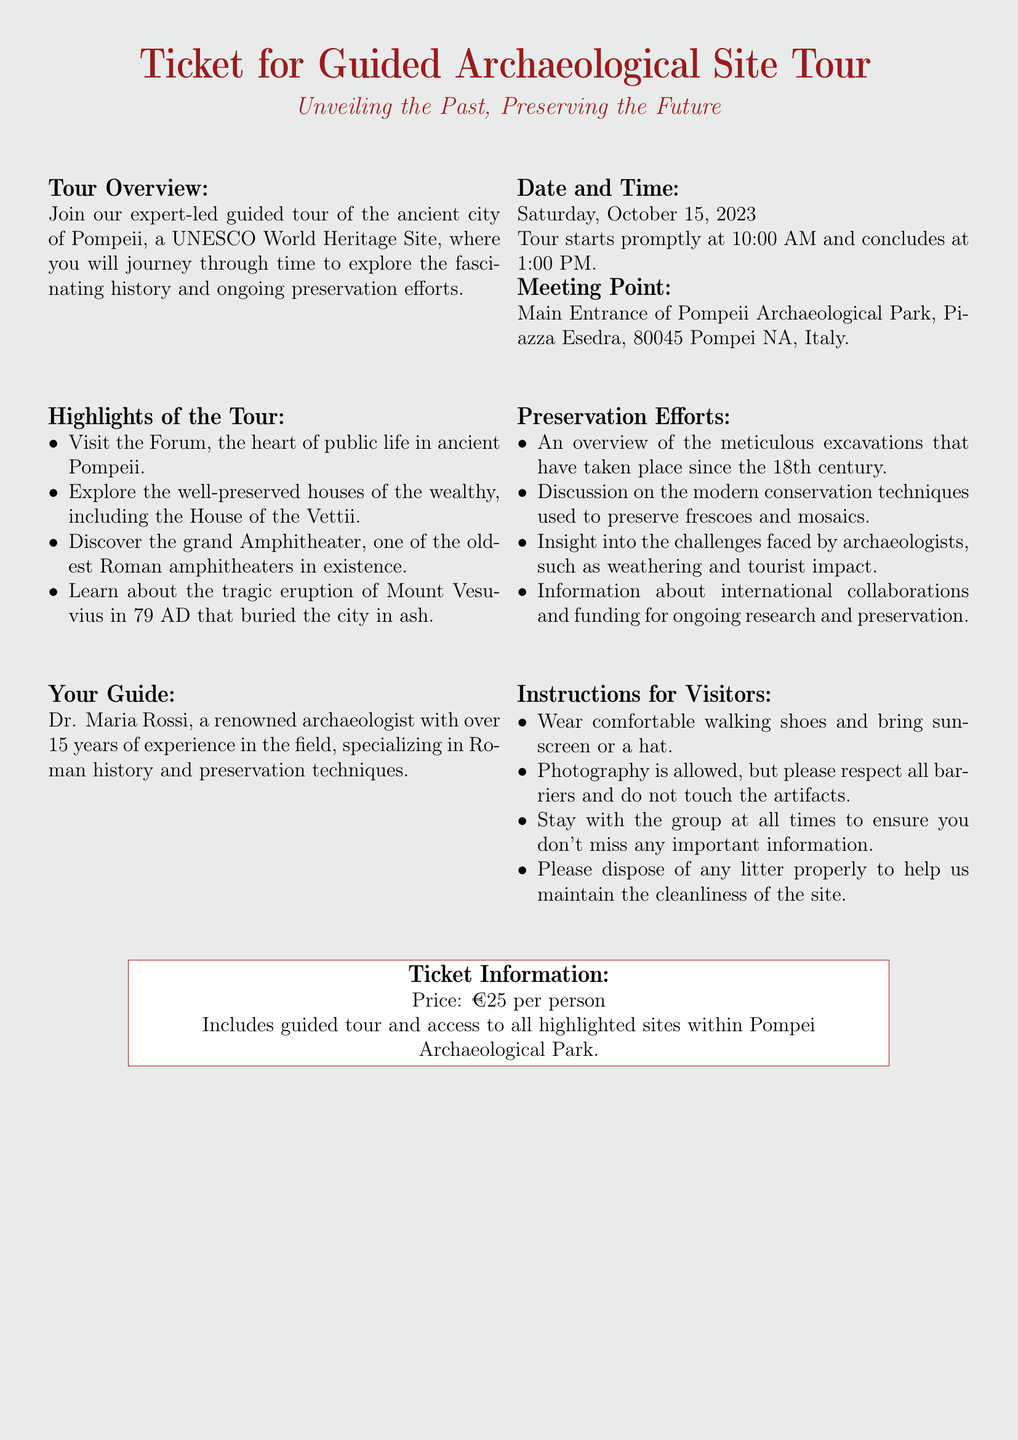What is the title of the tour? The title of the tour is prominently displayed at the top of the document as "Ticket for Guided Archaeological Site Tour."
Answer: Ticket for Guided Archaeological Site Tour Who is the guide for the tour? The guide for the tour is mentioned in the section titled "Your Guide."
Answer: Dr. Maria Rossi What date is the tour scheduled for? The date of the tour is located in the "Date and Time" section of the document.
Answer: Saturday, October 15, 2023 What time does the tour start? The starting time for the tour is given in the "Date and Time" section.
Answer: 10:00 AM What is the price of the ticket? The ticket price is specified in the "Ticket Information" box at the bottom of the document.
Answer: €25 per person What is one highlight of the tour? The highlights are listed in the "Highlights of the Tour" section, and this question asks for any single highlight.
Answer: Visit the Forum What challenges do archaeologists face, as mentioned in the document? The challenges faced by archaeologists are outlined in the "Preservation Efforts" section.
Answer: Weathering and tourist impact What should visitors wear for the tour? Instructions for visitors include what to wear, found in the "Instructions for Visitors" section.
Answer: Comfortable walking shoes 